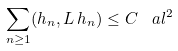<formula> <loc_0><loc_0><loc_500><loc_500>\sum _ { n \geq 1 } ( h _ { n } , L \, h _ { n } ) \leq C \, \ a l ^ { 2 }</formula> 